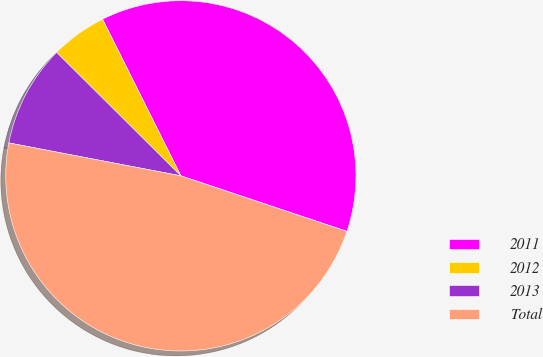Convert chart to OTSL. <chart><loc_0><loc_0><loc_500><loc_500><pie_chart><fcel>2011<fcel>2012<fcel>2013<fcel>Total<nl><fcel>37.52%<fcel>5.17%<fcel>9.44%<fcel>47.87%<nl></chart> 